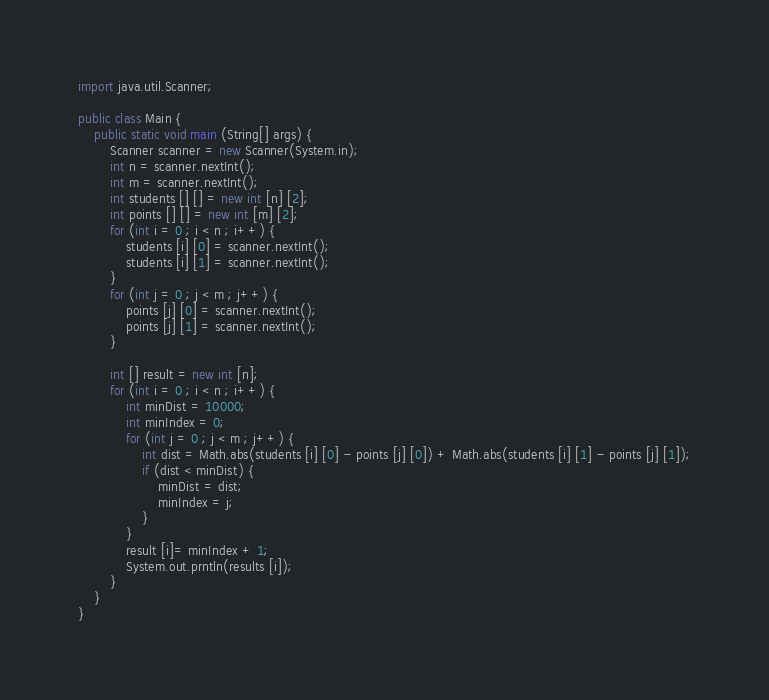Convert code to text. <code><loc_0><loc_0><loc_500><loc_500><_Java_>import java.util.Scanner;

public class Main {
	public static void main (String[] args) {
		Scanner scanner = new Scanner(System.in);
		int n = scanner.nextInt();
		int m = scanner.nextInt();
		int students [] [] = new int [n] [2];
		int points [] [] = new int [m] [2];
		for (int i = 0 ; i < n ; i++) {
			students [i] [0] = scanner.nextInt();
			students [i] [1] = scanner.nextInt();
		}
		for (int j = 0 ; j < m ; j++) {
			points [j] [0] = scanner.nextInt();
			points [j] [1] = scanner.nextInt();
		}
		
		int [] result = new int [n];
		for (int i = 0 ; i < n ; i++) {
			int minDist = 10000;
			int minIndex = 0;
			for (int j = 0 ; j < m ; j++) {
				int dist = Math.abs(students [i] [0] - points [j] [0]) + Math.abs(students [i] [1] - points [j] [1]);
				if (dist < minDist) {
					minDist = dist;
					minIndex = j;
				}
			}
			result [i]= minIndex + 1;
			System.out.prntln(results [i]);
		}
	}
} </code> 